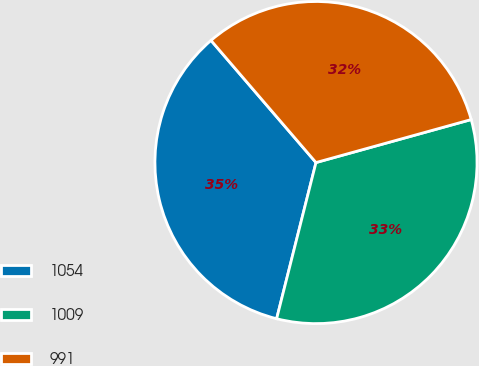Convert chart to OTSL. <chart><loc_0><loc_0><loc_500><loc_500><pie_chart><fcel>1054<fcel>1009<fcel>991<nl><fcel>34.77%<fcel>33.23%<fcel>32.0%<nl></chart> 